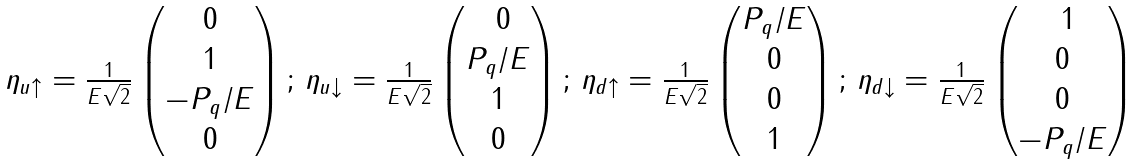Convert formula to latex. <formula><loc_0><loc_0><loc_500><loc_500>\begin{array} { c c c c } \eta _ { u \uparrow } = \frac { 1 } { E \sqrt { 2 } } \begin{pmatrix} 0 \\ 1 \\ - P _ { q } / E \\ 0 \end{pmatrix} ; \, \eta _ { u \downarrow } = \frac { 1 } { E \sqrt { 2 } } \begin{pmatrix} \ 0 \\ P _ { q } / E \\ 1 \\ 0 \end{pmatrix} ; \, \eta _ { d \uparrow } = \frac { 1 } { E \sqrt { 2 } } \begin{pmatrix} P _ { q } / E \\ 0 \\ 0 \\ 1 \end{pmatrix} ; \, \eta _ { d \downarrow } = \frac { 1 } { E \sqrt { 2 } } \begin{pmatrix} \ 1 \\ 0 \\ 0 \\ - P _ { q } / E \end{pmatrix} \end{array}</formula> 